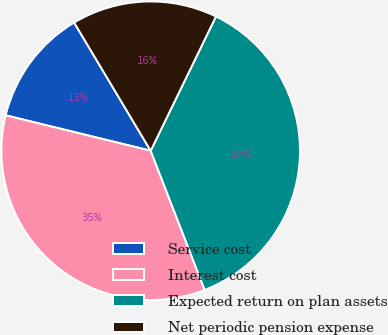Convert chart. <chart><loc_0><loc_0><loc_500><loc_500><pie_chart><fcel>Service cost<fcel>Interest cost<fcel>Expected return on plan assets<fcel>Net periodic pension expense<nl><fcel>12.62%<fcel>34.7%<fcel>36.91%<fcel>15.77%<nl></chart> 